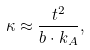Convert formula to latex. <formula><loc_0><loc_0><loc_500><loc_500>\kappa \approx \frac { t ^ { 2 } } { b \cdot k _ { A } } ,</formula> 